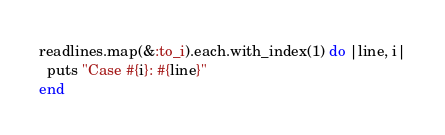Convert code to text. <code><loc_0><loc_0><loc_500><loc_500><_Ruby_>readlines.map(&:to_i).each.with_index(1) do |line, i|
  puts "Case #{i}: #{line}"
end</code> 